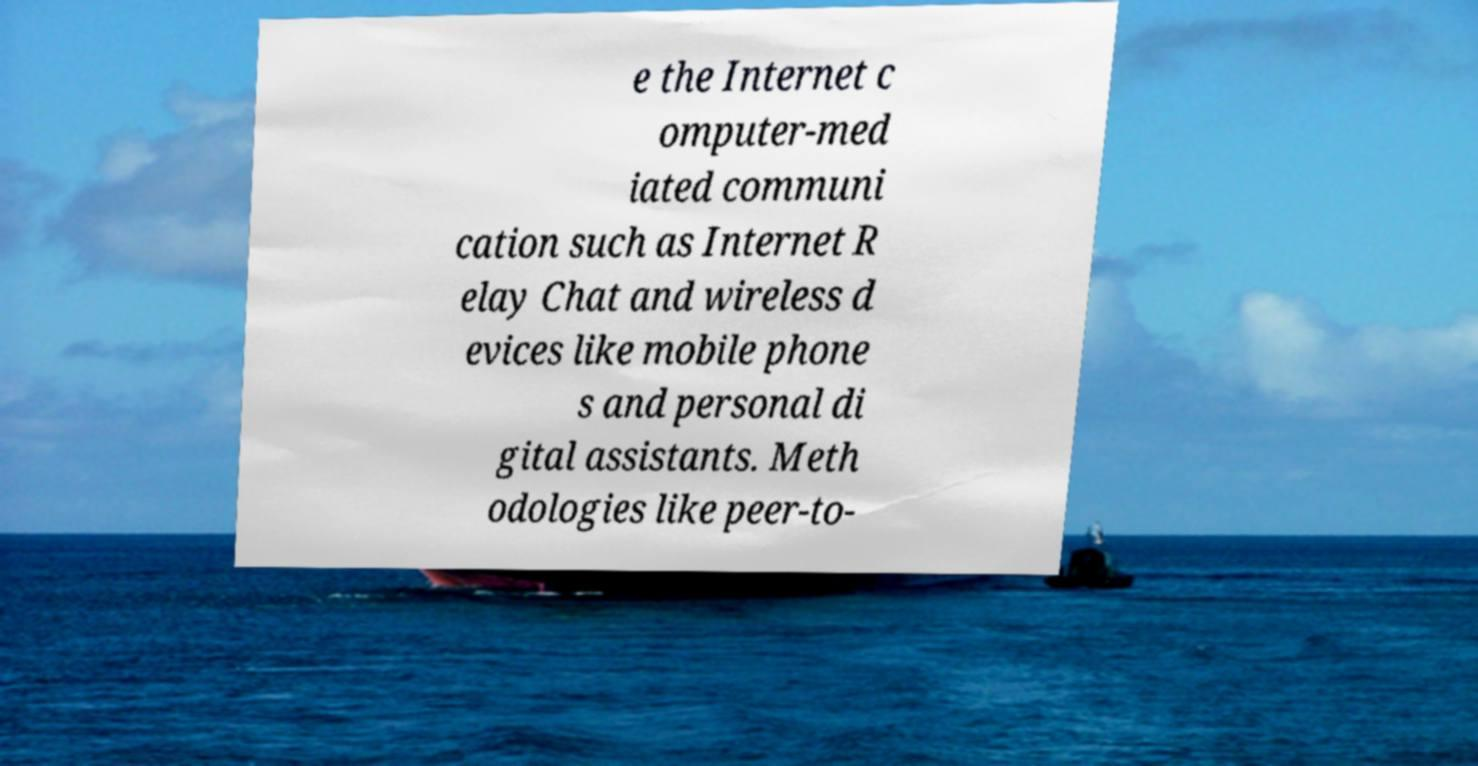Could you assist in decoding the text presented in this image and type it out clearly? e the Internet c omputer-med iated communi cation such as Internet R elay Chat and wireless d evices like mobile phone s and personal di gital assistants. Meth odologies like peer-to- 